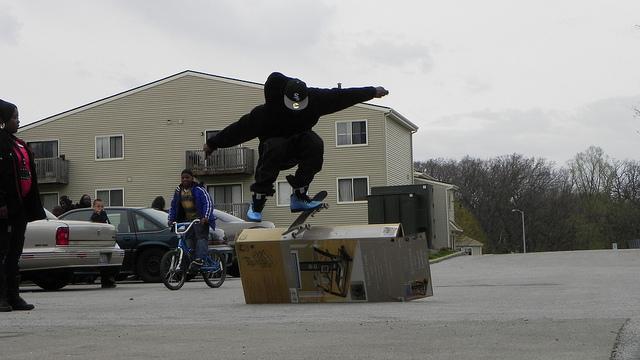What is the average size of skateboard?
Choose the correct response, then elucidate: 'Answer: answer
Rationale: rationale.'
Options: 9inches, 12inches, 15inches, 8inches. Answer: 8inches.
Rationale: The average skateboard is eight inches. 